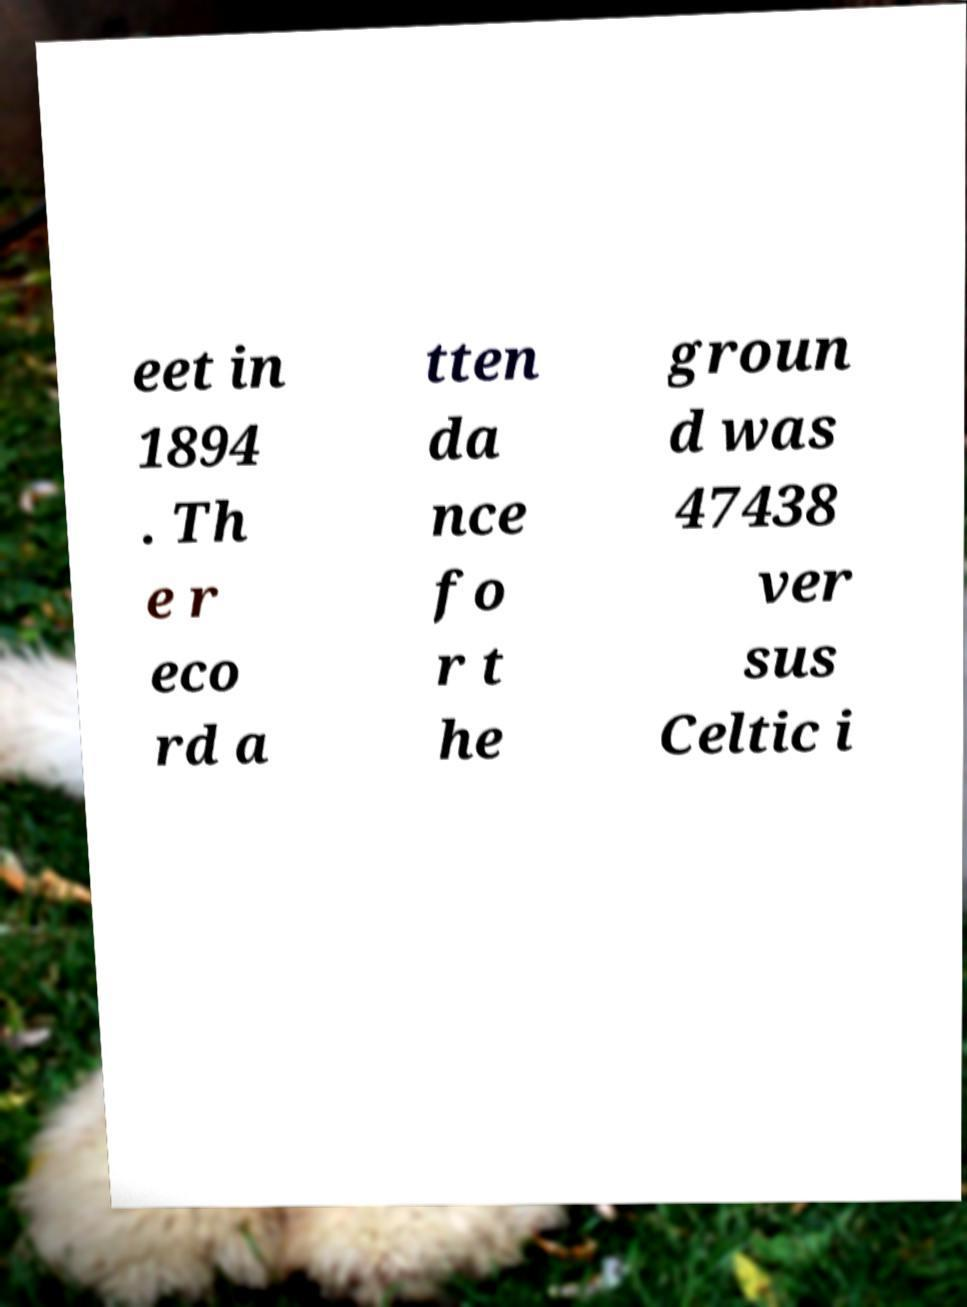There's text embedded in this image that I need extracted. Can you transcribe it verbatim? eet in 1894 . Th e r eco rd a tten da nce fo r t he groun d was 47438 ver sus Celtic i 